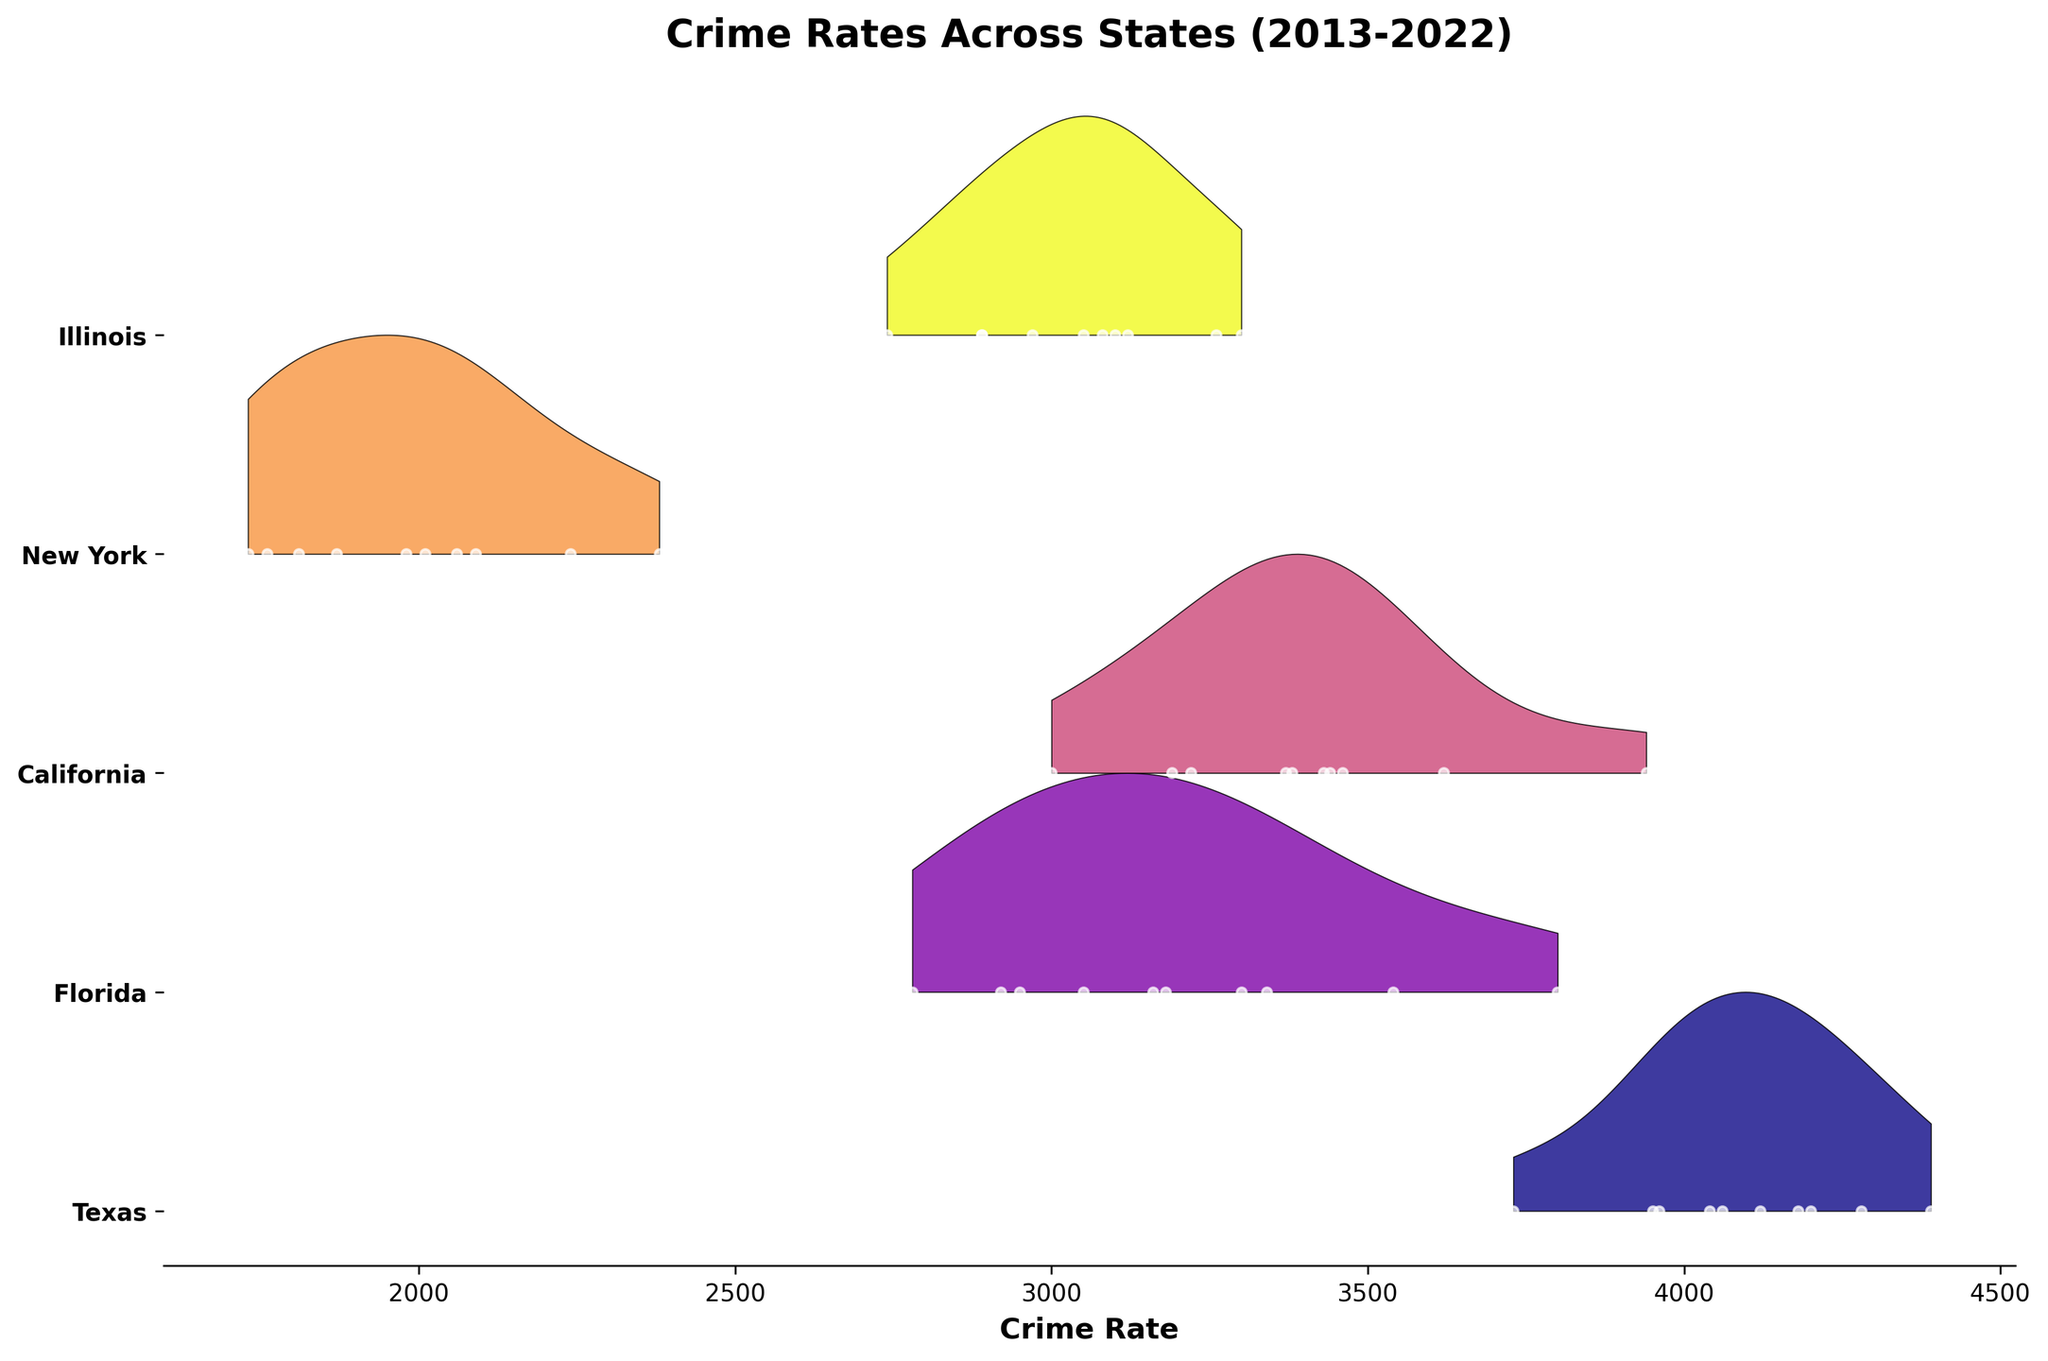What is the title of the plot? The title of the plot is located at the top of the figure, typically in a larger and bold font. It provides a brief description of what the plot represents.
Answer: Crime Rates Across States (2013-2022) How many states are represented in the plot? The states are represented by the ridgelines, which are labeled on the y-axis with their names. By counting these labels, we can determine the number of states shown.
Answer: 5 Which state had the highest crime rate in 2013? To determine this, look at the beginning of each state’s ridgeline and identify the highest value among the points labeled as "2013".
Answer: Texas Compare the crime rate trends in Texas and Florida. Which state experienced a more significant decrease over the decade? Look at the starting and ending points of the ridgeline for each state. Texas starts at a higher value and ends higher, while Florida shows a steady decline with a lower ending point than it started.
Answer: Florida What is the general trend in crime rates in New York over the decade? Observe the shape of the ridgeline for New York. It generally shows a decrease over time, then a slight increase towards the end, indicating an overall decrease with a recent slight uptick.
Answer: General decrease with a slight uptick For California, identify the period where the crime rate seems to have decreased the most. Examine the ridgeline for California and identify sections where the slope is steepest to show a significant decrease. The steepest decline appears from the years 2013 to 2014.
Answer: 2013-2014 Between Illinois and California, which state had a lower average crime rate throughout the decade? Visually estimating the position of the ridgelines around the middle of each state's range can help deduce which one had a lower average rate. California's ridgeline is generally lower than Illinois's.
Answer: California What can be inferred about the variability in crime rates for Illinois compared to New York? The width of the ridgelines and the spread of the points can show variability. Illinois has a wider spread in some years compared to the more tightly grouped points for New York, indicating higher variability in Illinois.
Answer: Illinois had higher variability In what year did the crime rate in New York rise sharply after a steady decrease? Looking closely at the trend in the New York ridgeline, a sharp rise is noted around 2020 after a steady decrease. The increase continues into 2021 and 2022.
Answer: 2020 Does the plot show any state with a constant or nearly constant crime rate trend across the period? By examining the ridgelines for each state, we notice that no state maintains a completely constant rate; however, California's ridgeline is relatively stable compared to others, showing minor fluctuations.
Answer: No state, but California is relatively stable 